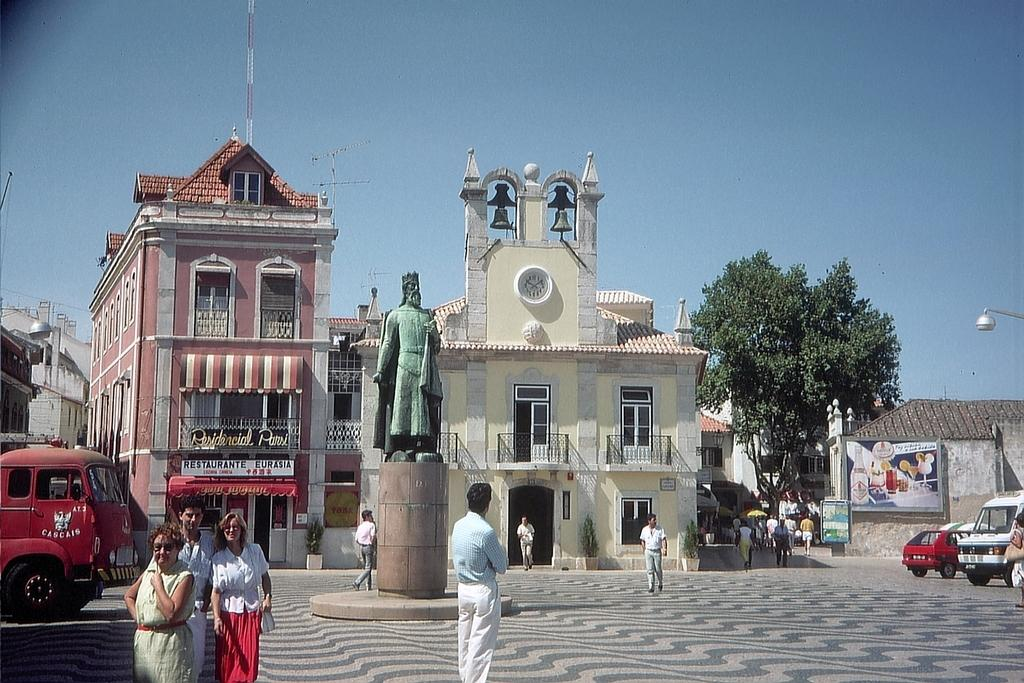What type of structures can be seen in the image? There are buildings with windows in the image. What object is present on the ground in the image? There is a try in the image. What else can be seen moving in the image? There are vehicles in the image. Are there any living beings visible in the image? Yes, people are standing in the image. What is visible above the buildings and people? The sky is visible in the image. How many jars are visible on the windows of the buildings in the image? There are no jars visible on the windows of the buildings in the image. Can you see any cows in the image? No, there are no cows present in the image. 